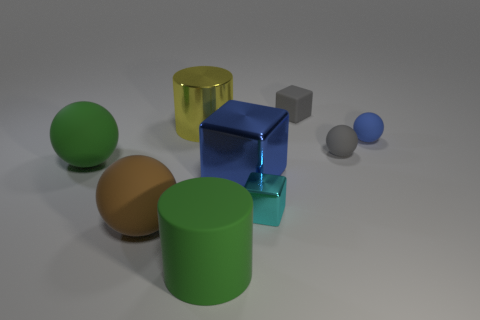Subtract all cylinders. How many objects are left? 7 Subtract 0 blue cylinders. How many objects are left? 9 Subtract all large green cylinders. Subtract all small red matte cylinders. How many objects are left? 8 Add 5 tiny objects. How many tiny objects are left? 9 Add 3 blue cubes. How many blue cubes exist? 4 